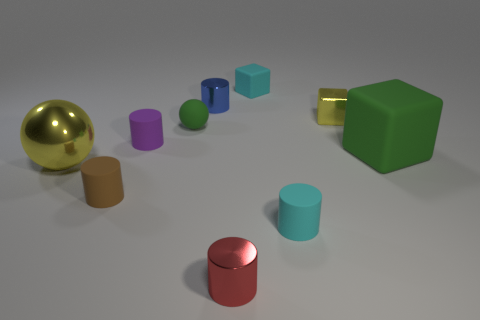The purple thing that is the same material as the small cyan cube is what shape?
Provide a succinct answer. Cylinder. Are there fewer yellow things that are on the left side of the tiny brown object than tiny green matte spheres?
Make the answer very short. No. Is the big green matte object the same shape as the brown matte thing?
Provide a short and direct response. No. How many rubber objects are either tiny blue things or small cubes?
Make the answer very short. 1. Are there any cyan matte cylinders that have the same size as the blue object?
Ensure brevity in your answer.  Yes. The big object that is the same color as the small metal block is what shape?
Your answer should be very brief. Sphere. What number of brown cylinders are the same size as the brown rubber thing?
Make the answer very short. 0. Does the rubber cube that is behind the small purple matte cylinder have the same size as the blue thing to the right of the small sphere?
Your answer should be compact. Yes. How many things are tiny rubber things or rubber spheres to the left of the metal block?
Offer a terse response. 5. What color is the big cube?
Give a very brief answer. Green. 